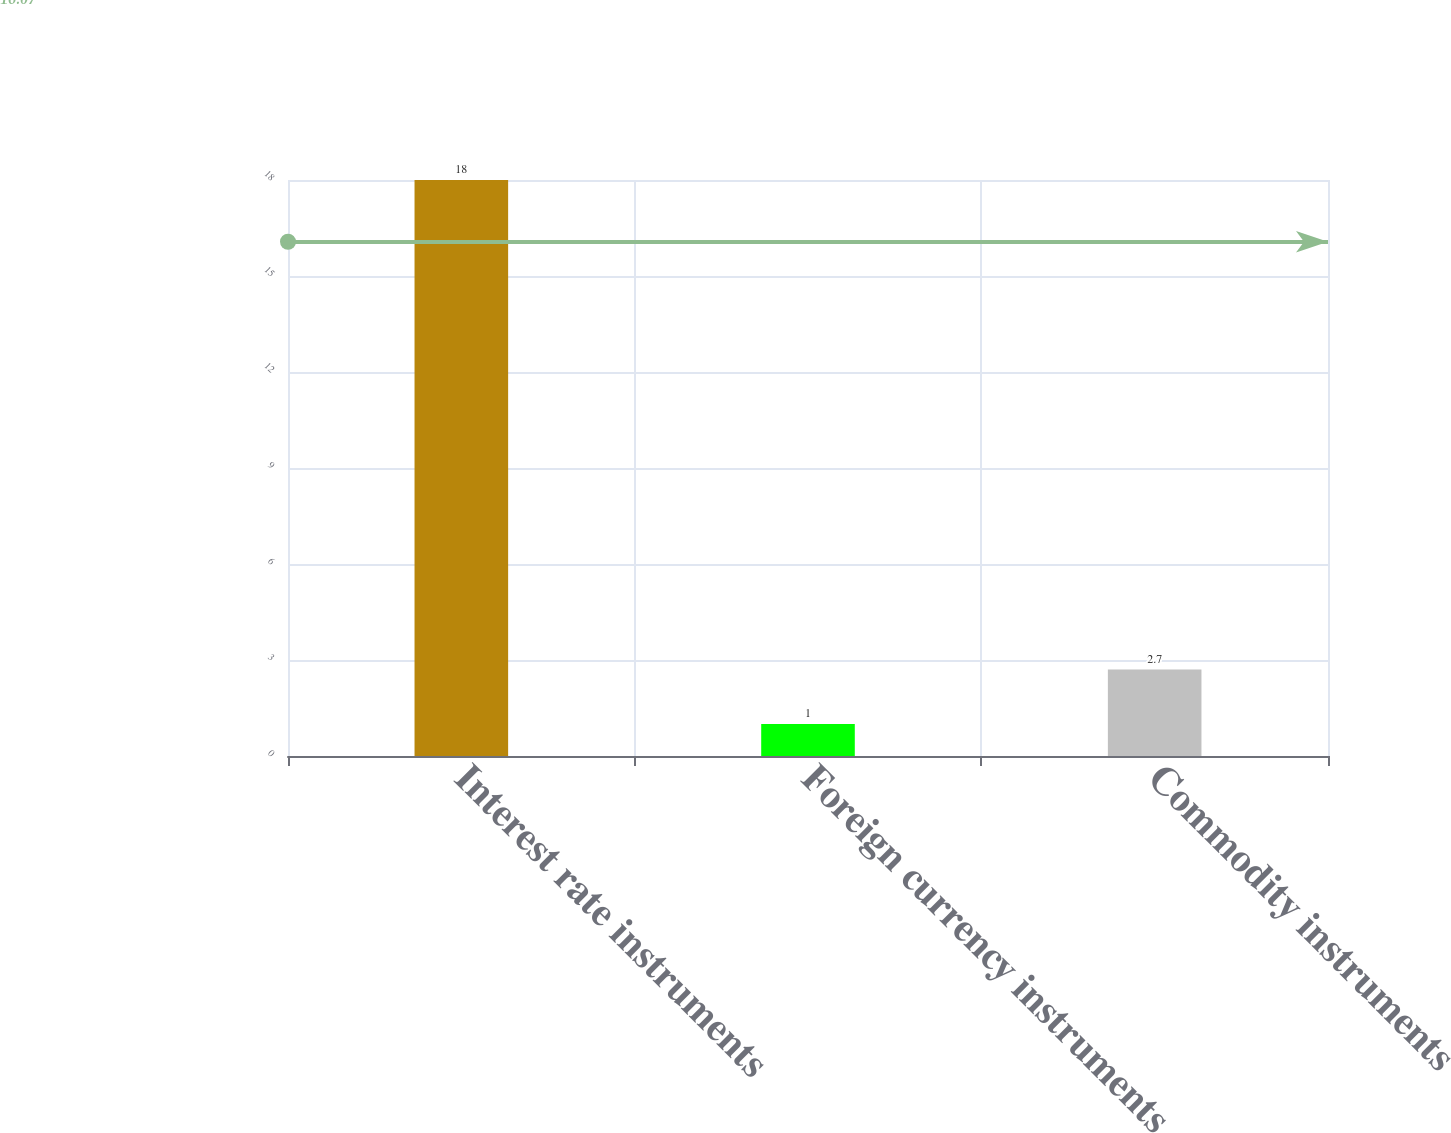Convert chart. <chart><loc_0><loc_0><loc_500><loc_500><bar_chart><fcel>Interest rate instruments<fcel>Foreign currency instruments<fcel>Commodity instruments<nl><fcel>18<fcel>1<fcel>2.7<nl></chart> 